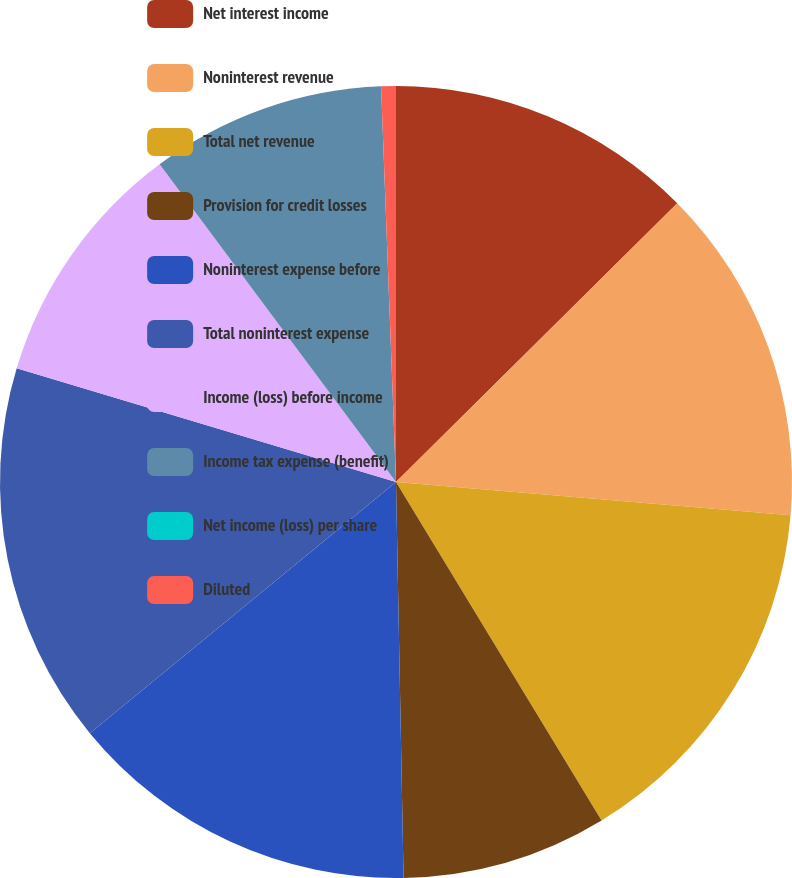Convert chart. <chart><loc_0><loc_0><loc_500><loc_500><pie_chart><fcel>Net interest income<fcel>Noninterest revenue<fcel>Total net revenue<fcel>Provision for credit losses<fcel>Noninterest expense before<fcel>Total noninterest expense<fcel>Income (loss) before income<fcel>Income tax expense (benefit)<fcel>Net income (loss) per share<fcel>Diluted<nl><fcel>12.57%<fcel>13.77%<fcel>14.97%<fcel>8.38%<fcel>14.37%<fcel>15.57%<fcel>10.18%<fcel>9.58%<fcel>0.0%<fcel>0.6%<nl></chart> 